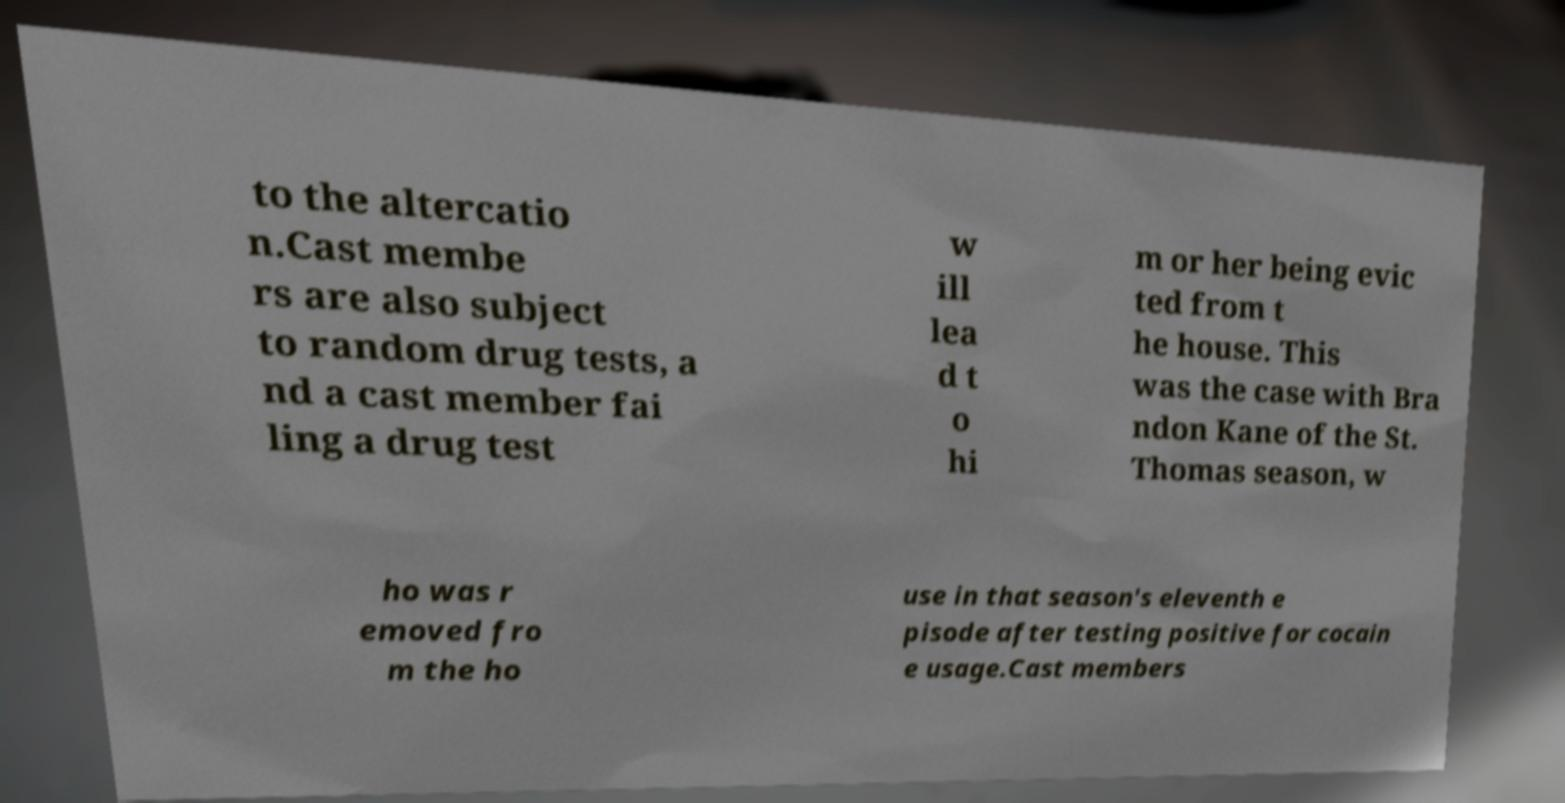Could you extract and type out the text from this image? to the altercatio n.Cast membe rs are also subject to random drug tests, a nd a cast member fai ling a drug test w ill lea d t o hi m or her being evic ted from t he house. This was the case with Bra ndon Kane of the St. Thomas season, w ho was r emoved fro m the ho use in that season's eleventh e pisode after testing positive for cocain e usage.Cast members 